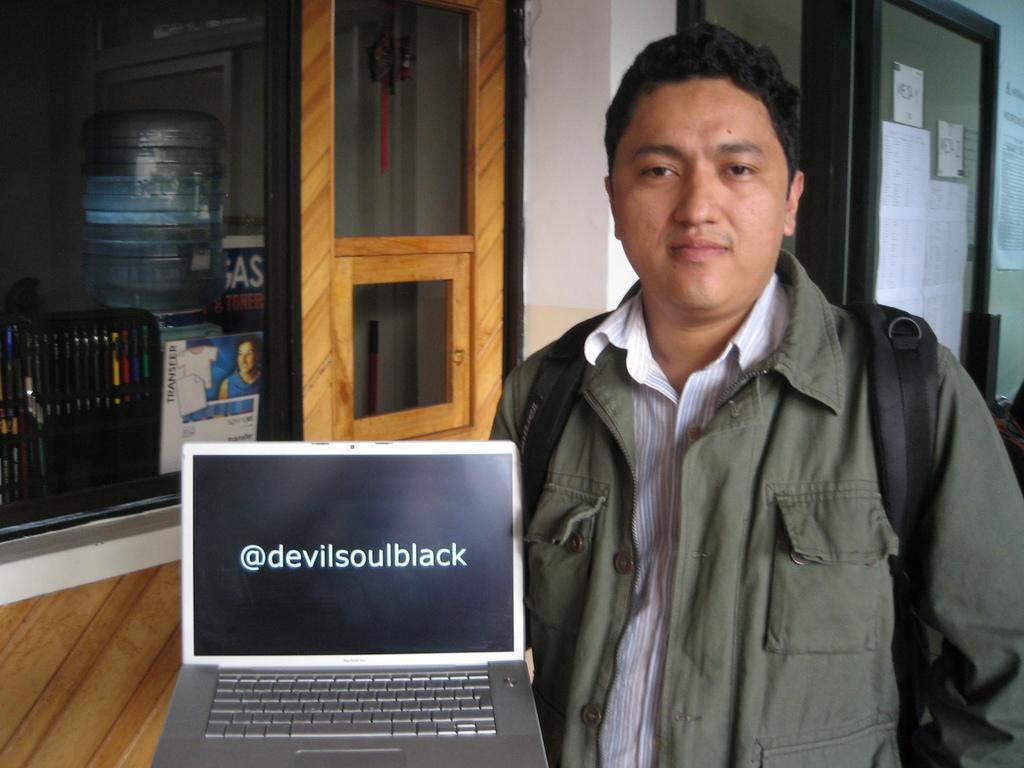How would you summarize this image in a sentence or two? In this image I can see a person holding a laptop and back side of the person I can see the wall and glass window and I can see another window on the right side , on the window I can see papers. 